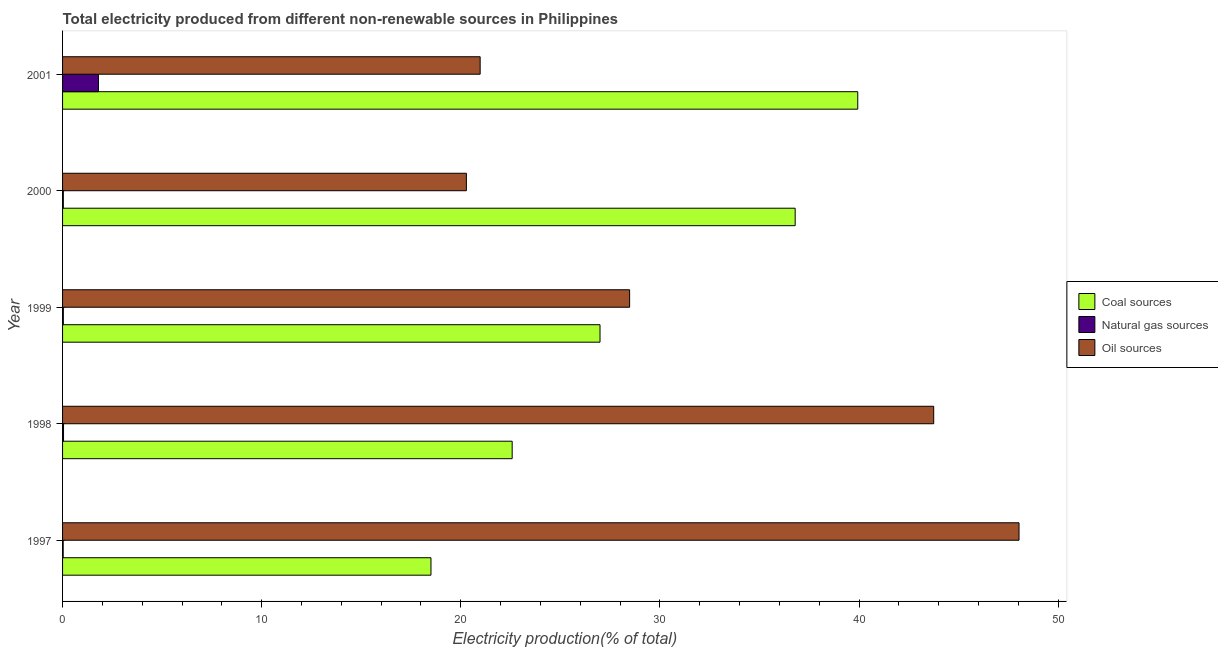How many groups of bars are there?
Offer a very short reply. 5. How many bars are there on the 5th tick from the top?
Keep it short and to the point. 3. What is the label of the 1st group of bars from the top?
Make the answer very short. 2001. In how many cases, is the number of bars for a given year not equal to the number of legend labels?
Ensure brevity in your answer.  0. What is the percentage of electricity produced by oil sources in 2000?
Your response must be concise. 20.28. Across all years, what is the maximum percentage of electricity produced by coal?
Your answer should be compact. 39.93. Across all years, what is the minimum percentage of electricity produced by oil sources?
Your response must be concise. 20.28. What is the total percentage of electricity produced by oil sources in the graph?
Keep it short and to the point. 161.51. What is the difference between the percentage of electricity produced by oil sources in 1999 and that in 2000?
Your response must be concise. 8.2. What is the difference between the percentage of electricity produced by natural gas in 1998 and the percentage of electricity produced by coal in 1999?
Offer a very short reply. -26.94. What is the average percentage of electricity produced by coal per year?
Keep it short and to the point. 28.96. In the year 2000, what is the difference between the percentage of electricity produced by coal and percentage of electricity produced by natural gas?
Offer a very short reply. 36.75. In how many years, is the percentage of electricity produced by oil sources greater than 30 %?
Offer a very short reply. 2. What is the ratio of the percentage of electricity produced by oil sources in 1998 to that in 2001?
Give a very brief answer. 2.09. Is the percentage of electricity produced by natural gas in 1999 less than that in 2001?
Give a very brief answer. Yes. Is the difference between the percentage of electricity produced by coal in 1998 and 1999 greater than the difference between the percentage of electricity produced by natural gas in 1998 and 1999?
Keep it short and to the point. No. What is the difference between the highest and the second highest percentage of electricity produced by natural gas?
Give a very brief answer. 1.75. What is the difference between the highest and the lowest percentage of electricity produced by natural gas?
Ensure brevity in your answer.  1.77. What does the 2nd bar from the top in 2000 represents?
Ensure brevity in your answer.  Natural gas sources. What does the 3rd bar from the bottom in 1999 represents?
Make the answer very short. Oil sources. How many bars are there?
Make the answer very short. 15. How many years are there in the graph?
Your answer should be compact. 5. Are the values on the major ticks of X-axis written in scientific E-notation?
Offer a very short reply. No. How many legend labels are there?
Provide a short and direct response. 3. What is the title of the graph?
Offer a very short reply. Total electricity produced from different non-renewable sources in Philippines. What is the label or title of the X-axis?
Give a very brief answer. Electricity production(% of total). What is the label or title of the Y-axis?
Provide a succinct answer. Year. What is the Electricity production(% of total) in Coal sources in 1997?
Your answer should be compact. 18.5. What is the Electricity production(% of total) of Natural gas sources in 1997?
Offer a very short reply. 0.03. What is the Electricity production(% of total) of Oil sources in 1997?
Offer a terse response. 48.03. What is the Electricity production(% of total) of Coal sources in 1998?
Ensure brevity in your answer.  22.58. What is the Electricity production(% of total) of Natural gas sources in 1998?
Your response must be concise. 0.05. What is the Electricity production(% of total) of Oil sources in 1998?
Offer a very short reply. 43.75. What is the Electricity production(% of total) in Coal sources in 1999?
Your response must be concise. 26.99. What is the Electricity production(% of total) in Natural gas sources in 1999?
Your answer should be very brief. 0.04. What is the Electricity production(% of total) in Oil sources in 1999?
Your response must be concise. 28.48. What is the Electricity production(% of total) of Coal sources in 2000?
Ensure brevity in your answer.  36.79. What is the Electricity production(% of total) in Natural gas sources in 2000?
Your answer should be compact. 0.04. What is the Electricity production(% of total) in Oil sources in 2000?
Provide a short and direct response. 20.28. What is the Electricity production(% of total) in Coal sources in 2001?
Provide a succinct answer. 39.93. What is the Electricity production(% of total) of Natural gas sources in 2001?
Give a very brief answer. 1.8. What is the Electricity production(% of total) in Oil sources in 2001?
Give a very brief answer. 20.97. Across all years, what is the maximum Electricity production(% of total) of Coal sources?
Keep it short and to the point. 39.93. Across all years, what is the maximum Electricity production(% of total) in Natural gas sources?
Provide a succinct answer. 1.8. Across all years, what is the maximum Electricity production(% of total) in Oil sources?
Keep it short and to the point. 48.03. Across all years, what is the minimum Electricity production(% of total) in Coal sources?
Give a very brief answer. 18.5. Across all years, what is the minimum Electricity production(% of total) in Natural gas sources?
Offer a very short reply. 0.03. Across all years, what is the minimum Electricity production(% of total) of Oil sources?
Your answer should be compact. 20.28. What is the total Electricity production(% of total) in Coal sources in the graph?
Provide a short and direct response. 144.8. What is the total Electricity production(% of total) of Natural gas sources in the graph?
Your response must be concise. 1.96. What is the total Electricity production(% of total) of Oil sources in the graph?
Provide a succinct answer. 161.51. What is the difference between the Electricity production(% of total) in Coal sources in 1997 and that in 1998?
Offer a very short reply. -4.08. What is the difference between the Electricity production(% of total) of Natural gas sources in 1997 and that in 1998?
Your answer should be compact. -0.02. What is the difference between the Electricity production(% of total) in Oil sources in 1997 and that in 1998?
Offer a very short reply. 4.28. What is the difference between the Electricity production(% of total) of Coal sources in 1997 and that in 1999?
Keep it short and to the point. -8.49. What is the difference between the Electricity production(% of total) in Natural gas sources in 1997 and that in 1999?
Keep it short and to the point. -0.01. What is the difference between the Electricity production(% of total) in Oil sources in 1997 and that in 1999?
Your answer should be very brief. 19.56. What is the difference between the Electricity production(% of total) of Coal sources in 1997 and that in 2000?
Offer a very short reply. -18.29. What is the difference between the Electricity production(% of total) of Natural gas sources in 1997 and that in 2000?
Provide a short and direct response. -0.01. What is the difference between the Electricity production(% of total) in Oil sources in 1997 and that in 2000?
Your answer should be compact. 27.75. What is the difference between the Electricity production(% of total) in Coal sources in 1997 and that in 2001?
Give a very brief answer. -21.43. What is the difference between the Electricity production(% of total) of Natural gas sources in 1997 and that in 2001?
Provide a short and direct response. -1.77. What is the difference between the Electricity production(% of total) of Oil sources in 1997 and that in 2001?
Ensure brevity in your answer.  27.06. What is the difference between the Electricity production(% of total) in Coal sources in 1998 and that in 1999?
Offer a terse response. -4.41. What is the difference between the Electricity production(% of total) in Natural gas sources in 1998 and that in 1999?
Ensure brevity in your answer.  0.01. What is the difference between the Electricity production(% of total) in Oil sources in 1998 and that in 1999?
Ensure brevity in your answer.  15.27. What is the difference between the Electricity production(% of total) in Coal sources in 1998 and that in 2000?
Provide a short and direct response. -14.21. What is the difference between the Electricity production(% of total) in Natural gas sources in 1998 and that in 2000?
Provide a short and direct response. 0.01. What is the difference between the Electricity production(% of total) in Oil sources in 1998 and that in 2000?
Offer a very short reply. 23.47. What is the difference between the Electricity production(% of total) in Coal sources in 1998 and that in 2001?
Your response must be concise. -17.35. What is the difference between the Electricity production(% of total) of Natural gas sources in 1998 and that in 2001?
Give a very brief answer. -1.75. What is the difference between the Electricity production(% of total) of Oil sources in 1998 and that in 2001?
Offer a very short reply. 22.78. What is the difference between the Electricity production(% of total) of Coal sources in 1999 and that in 2000?
Keep it short and to the point. -9.8. What is the difference between the Electricity production(% of total) of Natural gas sources in 1999 and that in 2000?
Provide a succinct answer. 0. What is the difference between the Electricity production(% of total) in Oil sources in 1999 and that in 2000?
Your answer should be compact. 8.2. What is the difference between the Electricity production(% of total) of Coal sources in 1999 and that in 2001?
Provide a short and direct response. -12.94. What is the difference between the Electricity production(% of total) of Natural gas sources in 1999 and that in 2001?
Keep it short and to the point. -1.76. What is the difference between the Electricity production(% of total) of Oil sources in 1999 and that in 2001?
Ensure brevity in your answer.  7.51. What is the difference between the Electricity production(% of total) of Coal sources in 2000 and that in 2001?
Ensure brevity in your answer.  -3.14. What is the difference between the Electricity production(% of total) in Natural gas sources in 2000 and that in 2001?
Ensure brevity in your answer.  -1.76. What is the difference between the Electricity production(% of total) in Oil sources in 2000 and that in 2001?
Offer a very short reply. -0.69. What is the difference between the Electricity production(% of total) in Coal sources in 1997 and the Electricity production(% of total) in Natural gas sources in 1998?
Provide a succinct answer. 18.45. What is the difference between the Electricity production(% of total) in Coal sources in 1997 and the Electricity production(% of total) in Oil sources in 1998?
Ensure brevity in your answer.  -25.25. What is the difference between the Electricity production(% of total) of Natural gas sources in 1997 and the Electricity production(% of total) of Oil sources in 1998?
Provide a short and direct response. -43.72. What is the difference between the Electricity production(% of total) in Coal sources in 1997 and the Electricity production(% of total) in Natural gas sources in 1999?
Provide a succinct answer. 18.46. What is the difference between the Electricity production(% of total) of Coal sources in 1997 and the Electricity production(% of total) of Oil sources in 1999?
Offer a very short reply. -9.98. What is the difference between the Electricity production(% of total) of Natural gas sources in 1997 and the Electricity production(% of total) of Oil sources in 1999?
Your answer should be very brief. -28.45. What is the difference between the Electricity production(% of total) of Coal sources in 1997 and the Electricity production(% of total) of Natural gas sources in 2000?
Your answer should be compact. 18.46. What is the difference between the Electricity production(% of total) in Coal sources in 1997 and the Electricity production(% of total) in Oil sources in 2000?
Your answer should be very brief. -1.78. What is the difference between the Electricity production(% of total) in Natural gas sources in 1997 and the Electricity production(% of total) in Oil sources in 2000?
Make the answer very short. -20.25. What is the difference between the Electricity production(% of total) in Coal sources in 1997 and the Electricity production(% of total) in Natural gas sources in 2001?
Your answer should be compact. 16.7. What is the difference between the Electricity production(% of total) of Coal sources in 1997 and the Electricity production(% of total) of Oil sources in 2001?
Your answer should be very brief. -2.47. What is the difference between the Electricity production(% of total) in Natural gas sources in 1997 and the Electricity production(% of total) in Oil sources in 2001?
Keep it short and to the point. -20.94. What is the difference between the Electricity production(% of total) in Coal sources in 1998 and the Electricity production(% of total) in Natural gas sources in 1999?
Offer a very short reply. 22.54. What is the difference between the Electricity production(% of total) of Coal sources in 1998 and the Electricity production(% of total) of Oil sources in 1999?
Ensure brevity in your answer.  -5.9. What is the difference between the Electricity production(% of total) of Natural gas sources in 1998 and the Electricity production(% of total) of Oil sources in 1999?
Your answer should be very brief. -28.43. What is the difference between the Electricity production(% of total) in Coal sources in 1998 and the Electricity production(% of total) in Natural gas sources in 2000?
Provide a succinct answer. 22.54. What is the difference between the Electricity production(% of total) in Coal sources in 1998 and the Electricity production(% of total) in Oil sources in 2000?
Ensure brevity in your answer.  2.3. What is the difference between the Electricity production(% of total) in Natural gas sources in 1998 and the Electricity production(% of total) in Oil sources in 2000?
Make the answer very short. -20.23. What is the difference between the Electricity production(% of total) of Coal sources in 1998 and the Electricity production(% of total) of Natural gas sources in 2001?
Your answer should be compact. 20.78. What is the difference between the Electricity production(% of total) of Coal sources in 1998 and the Electricity production(% of total) of Oil sources in 2001?
Ensure brevity in your answer.  1.61. What is the difference between the Electricity production(% of total) in Natural gas sources in 1998 and the Electricity production(% of total) in Oil sources in 2001?
Your answer should be very brief. -20.92. What is the difference between the Electricity production(% of total) of Coal sources in 1999 and the Electricity production(% of total) of Natural gas sources in 2000?
Provide a short and direct response. 26.95. What is the difference between the Electricity production(% of total) in Coal sources in 1999 and the Electricity production(% of total) in Oil sources in 2000?
Ensure brevity in your answer.  6.71. What is the difference between the Electricity production(% of total) of Natural gas sources in 1999 and the Electricity production(% of total) of Oil sources in 2000?
Your answer should be very brief. -20.24. What is the difference between the Electricity production(% of total) of Coal sources in 1999 and the Electricity production(% of total) of Natural gas sources in 2001?
Your response must be concise. 25.19. What is the difference between the Electricity production(% of total) in Coal sources in 1999 and the Electricity production(% of total) in Oil sources in 2001?
Offer a terse response. 6.02. What is the difference between the Electricity production(% of total) in Natural gas sources in 1999 and the Electricity production(% of total) in Oil sources in 2001?
Provide a succinct answer. -20.93. What is the difference between the Electricity production(% of total) in Coal sources in 2000 and the Electricity production(% of total) in Natural gas sources in 2001?
Keep it short and to the point. 34.99. What is the difference between the Electricity production(% of total) in Coal sources in 2000 and the Electricity production(% of total) in Oil sources in 2001?
Provide a succinct answer. 15.82. What is the difference between the Electricity production(% of total) in Natural gas sources in 2000 and the Electricity production(% of total) in Oil sources in 2001?
Provide a short and direct response. -20.93. What is the average Electricity production(% of total) in Coal sources per year?
Your answer should be compact. 28.96. What is the average Electricity production(% of total) of Natural gas sources per year?
Offer a very short reply. 0.39. What is the average Electricity production(% of total) of Oil sources per year?
Make the answer very short. 32.3. In the year 1997, what is the difference between the Electricity production(% of total) of Coal sources and Electricity production(% of total) of Natural gas sources?
Offer a terse response. 18.47. In the year 1997, what is the difference between the Electricity production(% of total) in Coal sources and Electricity production(% of total) in Oil sources?
Keep it short and to the point. -29.53. In the year 1997, what is the difference between the Electricity production(% of total) in Natural gas sources and Electricity production(% of total) in Oil sources?
Provide a short and direct response. -48. In the year 1998, what is the difference between the Electricity production(% of total) of Coal sources and Electricity production(% of total) of Natural gas sources?
Offer a terse response. 22.53. In the year 1998, what is the difference between the Electricity production(% of total) of Coal sources and Electricity production(% of total) of Oil sources?
Your answer should be compact. -21.17. In the year 1998, what is the difference between the Electricity production(% of total) in Natural gas sources and Electricity production(% of total) in Oil sources?
Make the answer very short. -43.7. In the year 1999, what is the difference between the Electricity production(% of total) of Coal sources and Electricity production(% of total) of Natural gas sources?
Ensure brevity in your answer.  26.95. In the year 1999, what is the difference between the Electricity production(% of total) of Coal sources and Electricity production(% of total) of Oil sources?
Provide a short and direct response. -1.49. In the year 1999, what is the difference between the Electricity production(% of total) of Natural gas sources and Electricity production(% of total) of Oil sources?
Your answer should be very brief. -28.44. In the year 2000, what is the difference between the Electricity production(% of total) of Coal sources and Electricity production(% of total) of Natural gas sources?
Provide a short and direct response. 36.75. In the year 2000, what is the difference between the Electricity production(% of total) of Coal sources and Electricity production(% of total) of Oil sources?
Give a very brief answer. 16.51. In the year 2000, what is the difference between the Electricity production(% of total) of Natural gas sources and Electricity production(% of total) of Oil sources?
Provide a short and direct response. -20.24. In the year 2001, what is the difference between the Electricity production(% of total) in Coal sources and Electricity production(% of total) in Natural gas sources?
Your response must be concise. 38.13. In the year 2001, what is the difference between the Electricity production(% of total) of Coal sources and Electricity production(% of total) of Oil sources?
Ensure brevity in your answer.  18.96. In the year 2001, what is the difference between the Electricity production(% of total) in Natural gas sources and Electricity production(% of total) in Oil sources?
Offer a very short reply. -19.17. What is the ratio of the Electricity production(% of total) in Coal sources in 1997 to that in 1998?
Provide a short and direct response. 0.82. What is the ratio of the Electricity production(% of total) in Natural gas sources in 1997 to that in 1998?
Give a very brief answer. 0.63. What is the ratio of the Electricity production(% of total) of Oil sources in 1997 to that in 1998?
Make the answer very short. 1.1. What is the ratio of the Electricity production(% of total) in Coal sources in 1997 to that in 1999?
Make the answer very short. 0.69. What is the ratio of the Electricity production(% of total) in Natural gas sources in 1997 to that in 1999?
Your answer should be very brief. 0.78. What is the ratio of the Electricity production(% of total) of Oil sources in 1997 to that in 1999?
Your answer should be compact. 1.69. What is the ratio of the Electricity production(% of total) of Coal sources in 1997 to that in 2000?
Your response must be concise. 0.5. What is the ratio of the Electricity production(% of total) in Natural gas sources in 1997 to that in 2000?
Make the answer very short. 0.8. What is the ratio of the Electricity production(% of total) of Oil sources in 1997 to that in 2000?
Make the answer very short. 2.37. What is the ratio of the Electricity production(% of total) of Coal sources in 1997 to that in 2001?
Give a very brief answer. 0.46. What is the ratio of the Electricity production(% of total) of Natural gas sources in 1997 to that in 2001?
Your answer should be compact. 0.02. What is the ratio of the Electricity production(% of total) in Oil sources in 1997 to that in 2001?
Make the answer very short. 2.29. What is the ratio of the Electricity production(% of total) of Coal sources in 1998 to that in 1999?
Ensure brevity in your answer.  0.84. What is the ratio of the Electricity production(% of total) of Natural gas sources in 1998 to that in 1999?
Your answer should be very brief. 1.25. What is the ratio of the Electricity production(% of total) in Oil sources in 1998 to that in 1999?
Ensure brevity in your answer.  1.54. What is the ratio of the Electricity production(% of total) in Coal sources in 1998 to that in 2000?
Give a very brief answer. 0.61. What is the ratio of the Electricity production(% of total) in Natural gas sources in 1998 to that in 2000?
Provide a short and direct response. 1.28. What is the ratio of the Electricity production(% of total) in Oil sources in 1998 to that in 2000?
Your response must be concise. 2.16. What is the ratio of the Electricity production(% of total) in Coal sources in 1998 to that in 2001?
Your response must be concise. 0.57. What is the ratio of the Electricity production(% of total) in Natural gas sources in 1998 to that in 2001?
Provide a short and direct response. 0.03. What is the ratio of the Electricity production(% of total) in Oil sources in 1998 to that in 2001?
Ensure brevity in your answer.  2.09. What is the ratio of the Electricity production(% of total) of Coal sources in 1999 to that in 2000?
Provide a succinct answer. 0.73. What is the ratio of the Electricity production(% of total) of Natural gas sources in 1999 to that in 2000?
Offer a very short reply. 1.03. What is the ratio of the Electricity production(% of total) in Oil sources in 1999 to that in 2000?
Make the answer very short. 1.4. What is the ratio of the Electricity production(% of total) of Coal sources in 1999 to that in 2001?
Give a very brief answer. 0.68. What is the ratio of the Electricity production(% of total) of Natural gas sources in 1999 to that in 2001?
Offer a terse response. 0.02. What is the ratio of the Electricity production(% of total) in Oil sources in 1999 to that in 2001?
Your answer should be compact. 1.36. What is the ratio of the Electricity production(% of total) in Coal sources in 2000 to that in 2001?
Ensure brevity in your answer.  0.92. What is the ratio of the Electricity production(% of total) in Natural gas sources in 2000 to that in 2001?
Ensure brevity in your answer.  0.02. What is the ratio of the Electricity production(% of total) of Oil sources in 2000 to that in 2001?
Your answer should be compact. 0.97. What is the difference between the highest and the second highest Electricity production(% of total) of Coal sources?
Your answer should be very brief. 3.14. What is the difference between the highest and the second highest Electricity production(% of total) of Natural gas sources?
Provide a succinct answer. 1.75. What is the difference between the highest and the second highest Electricity production(% of total) of Oil sources?
Provide a succinct answer. 4.28. What is the difference between the highest and the lowest Electricity production(% of total) in Coal sources?
Ensure brevity in your answer.  21.43. What is the difference between the highest and the lowest Electricity production(% of total) in Natural gas sources?
Your answer should be compact. 1.77. What is the difference between the highest and the lowest Electricity production(% of total) in Oil sources?
Ensure brevity in your answer.  27.75. 